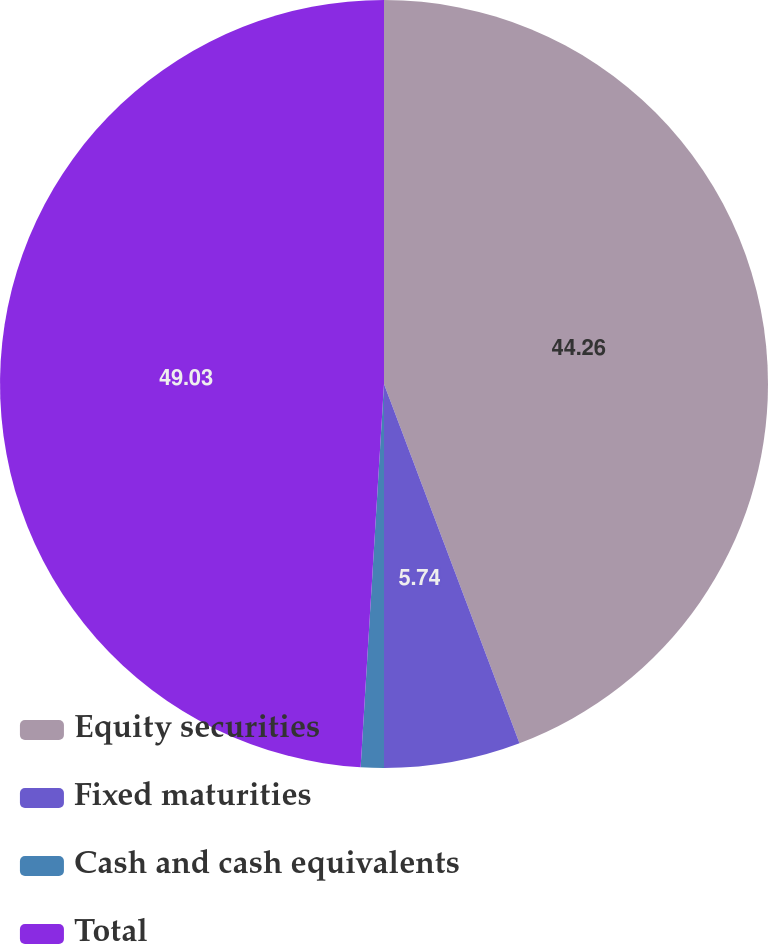Convert chart. <chart><loc_0><loc_0><loc_500><loc_500><pie_chart><fcel>Equity securities<fcel>Fixed maturities<fcel>Cash and cash equivalents<fcel>Total<nl><fcel>44.26%<fcel>5.74%<fcel>0.97%<fcel>49.03%<nl></chart> 